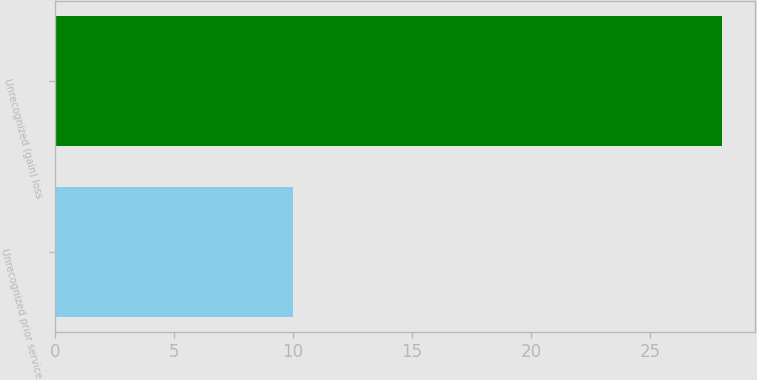Convert chart to OTSL. <chart><loc_0><loc_0><loc_500><loc_500><bar_chart><fcel>Unrecognized prior service<fcel>Unrecognized (gain) loss<nl><fcel>10<fcel>28<nl></chart> 